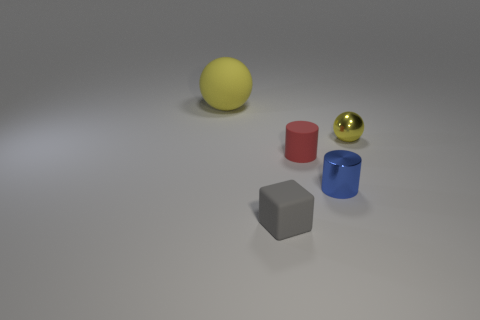Add 1 tiny metallic objects. How many objects exist? 6 Subtract all cylinders. How many objects are left? 3 Add 1 small rubber objects. How many small rubber objects exist? 3 Subtract 0 blue cubes. How many objects are left? 5 Subtract all green blocks. Subtract all green spheres. How many blocks are left? 1 Subtract all blue metal objects. Subtract all big yellow rubber spheres. How many objects are left? 3 Add 1 small metallic things. How many small metallic things are left? 3 